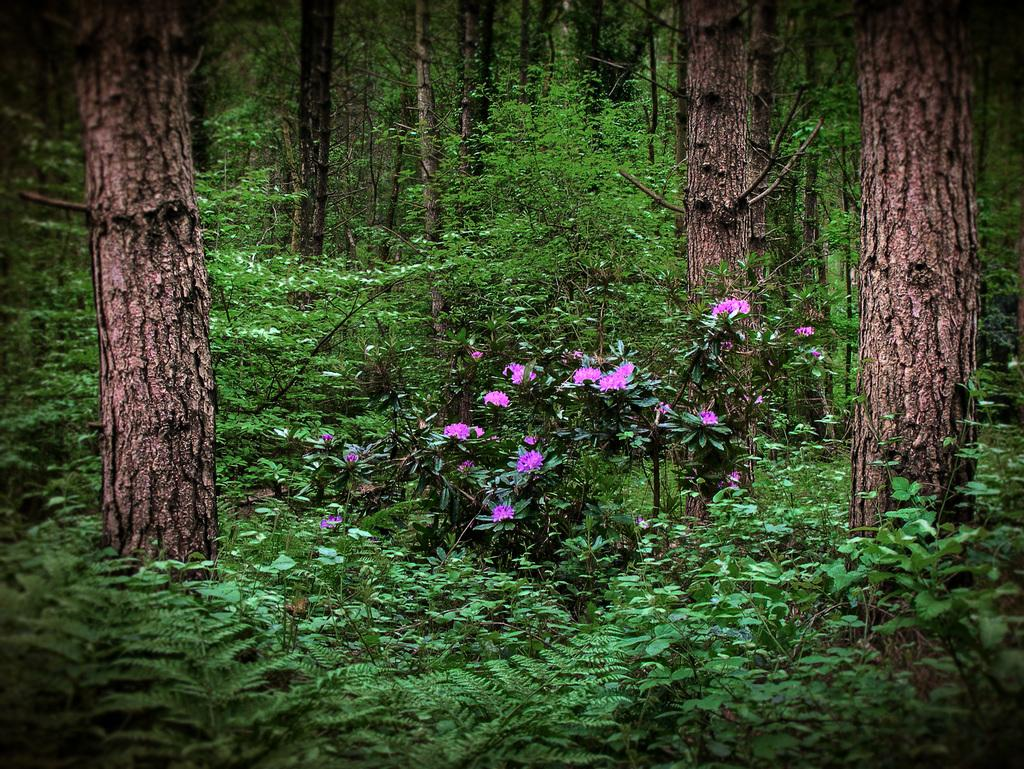What type of living organisms can be seen in the image? Plants, flowers, and trees can be seen in the image. Can you describe the specific types of plants in the image? The image features flowers and trees. What type of potato is being used to water the plants in the image? There is no potato present in the image, and therefore no such activity can be observed. Can you tell me how many boats are visible in the image? There are no boats present in the image. 